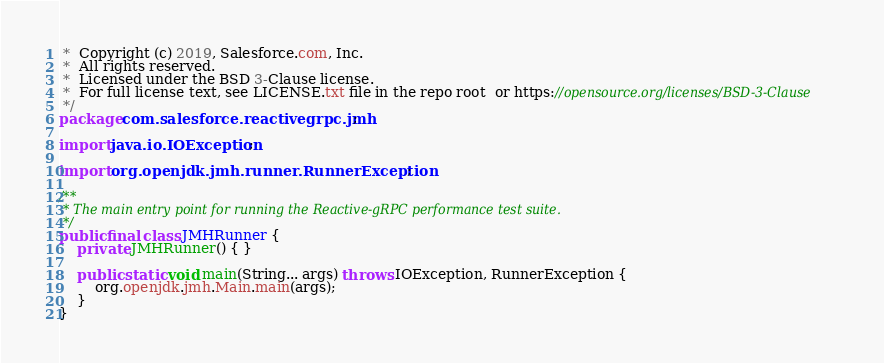Convert code to text. <code><loc_0><loc_0><loc_500><loc_500><_Java_> *  Copyright (c) 2019, Salesforce.com, Inc.
 *  All rights reserved.
 *  Licensed under the BSD 3-Clause license.
 *  For full license text, see LICENSE.txt file in the repo root  or https://opensource.org/licenses/BSD-3-Clause
 */
package com.salesforce.reactivegrpc.jmh;

import java.io.IOException;

import org.openjdk.jmh.runner.RunnerException;

/**
 * The main entry point for running the Reactive-gRPC performance test suite.
 */
public final class JMHRunner {
    private JMHRunner() { }

    public static void main(String... args) throws IOException, RunnerException {
        org.openjdk.jmh.Main.main(args);
    }
}
</code> 